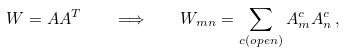Convert formula to latex. <formula><loc_0><loc_0><loc_500><loc_500>W = A A ^ { T } \quad \Longrightarrow \quad W _ { m n } = \sum _ { c ( o p e n ) } A _ { m } ^ { c } A _ { n } ^ { c } \, ,</formula> 